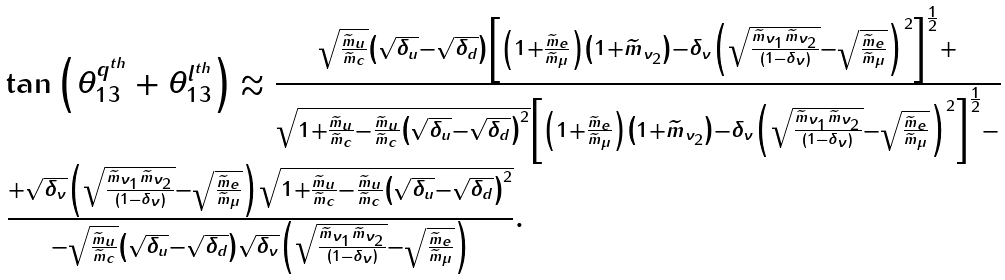<formula> <loc_0><loc_0><loc_500><loc_500>\begin{array} { l } \tan { \left ( \theta _ { 1 3 } ^ { q ^ { t h } } + \theta _ { 1 3 } ^ { l ^ { t h } } \right ) } \approx \frac { \sqrt { \frac { \widetilde { m } _ { u } } { \widetilde { m } _ { c } } } \left ( \sqrt { \delta _ { u } } - \sqrt { \delta _ { d } } \right ) \left [ \left ( 1 + \frac { \widetilde { m } _ { e } } { \widetilde { m } _ { \mu } } \right ) \left ( 1 + \widetilde { m } _ { \nu _ { 2 } } \right ) - \delta _ { \nu } \left ( \sqrt { \frac { \widetilde { m } _ { \nu _ { 1 } } \widetilde { m } _ { \nu _ { 2 } } } { \left ( 1 - \delta _ { \nu } \right ) } } - \sqrt { \frac { \widetilde { m } _ { e } } { \widetilde { m } _ { \mu } } } \right ) ^ { 2 } \right ] ^ { \frac { 1 } { 2 } } + } { \sqrt { 1 + \frac { \widetilde { m } _ { u } } { \widetilde { m } _ { c } } - \frac { \widetilde { m } _ { u } } { \widetilde { m } _ { c } } \left ( \sqrt { \delta _ { u } } - \sqrt { \delta _ { d } } \right ) ^ { 2 } } \left [ \left ( 1 + \frac { \widetilde { m } _ { e } } { \widetilde { m } _ { \mu } } \right ) \left ( 1 + \widetilde { m } _ { \nu _ { 2 } } \right ) - \delta _ { \nu } \left ( \sqrt { \frac { \widetilde { m } _ { \nu _ { 1 } } \widetilde { m } _ { \nu _ { 2 } } } { \left ( 1 - \delta _ { \nu } \right ) } } - \sqrt { \frac { \widetilde { m } _ { e } } { \widetilde { m } _ { \mu } } } \right ) ^ { 2 } \right ] ^ { \frac { 1 } { 2 } } - } \\ \frac { + \sqrt { \delta _ { \nu } } \left ( \sqrt { \frac { \widetilde { m } _ { \nu _ { 1 } } \widetilde { m } _ { \nu _ { 2 } } } { \left ( 1 - \delta _ { \nu } \right ) } } - \sqrt { \frac { \widetilde { m } _ { e } } { \widetilde { m } _ { \mu } } } \right ) \sqrt { 1 + \frac { \widetilde { m } _ { u } } { \widetilde { m } _ { c } } - \frac { \widetilde { m } _ { u } } { \widetilde { m } _ { c } } \left ( \sqrt { \delta _ { u } } - \sqrt { \delta _ { d } } \right ) ^ { 2 } } } { - \sqrt { \frac { \widetilde { m } _ { u } } { \widetilde { m } _ { c } } } \left ( \sqrt { \delta _ { u } } - \sqrt { \delta _ { d } } \right ) \sqrt { \delta _ { \nu } } \left ( \sqrt { \frac { \widetilde { m } _ { \nu _ { 1 } } \widetilde { m } _ { \nu _ { 2 } } } { \left ( 1 - \delta _ { \nu } \right ) } } - \sqrt { \frac { \widetilde { m } _ { e } } { \widetilde { m } _ { \mu } } } \right ) } . \end{array}</formula> 